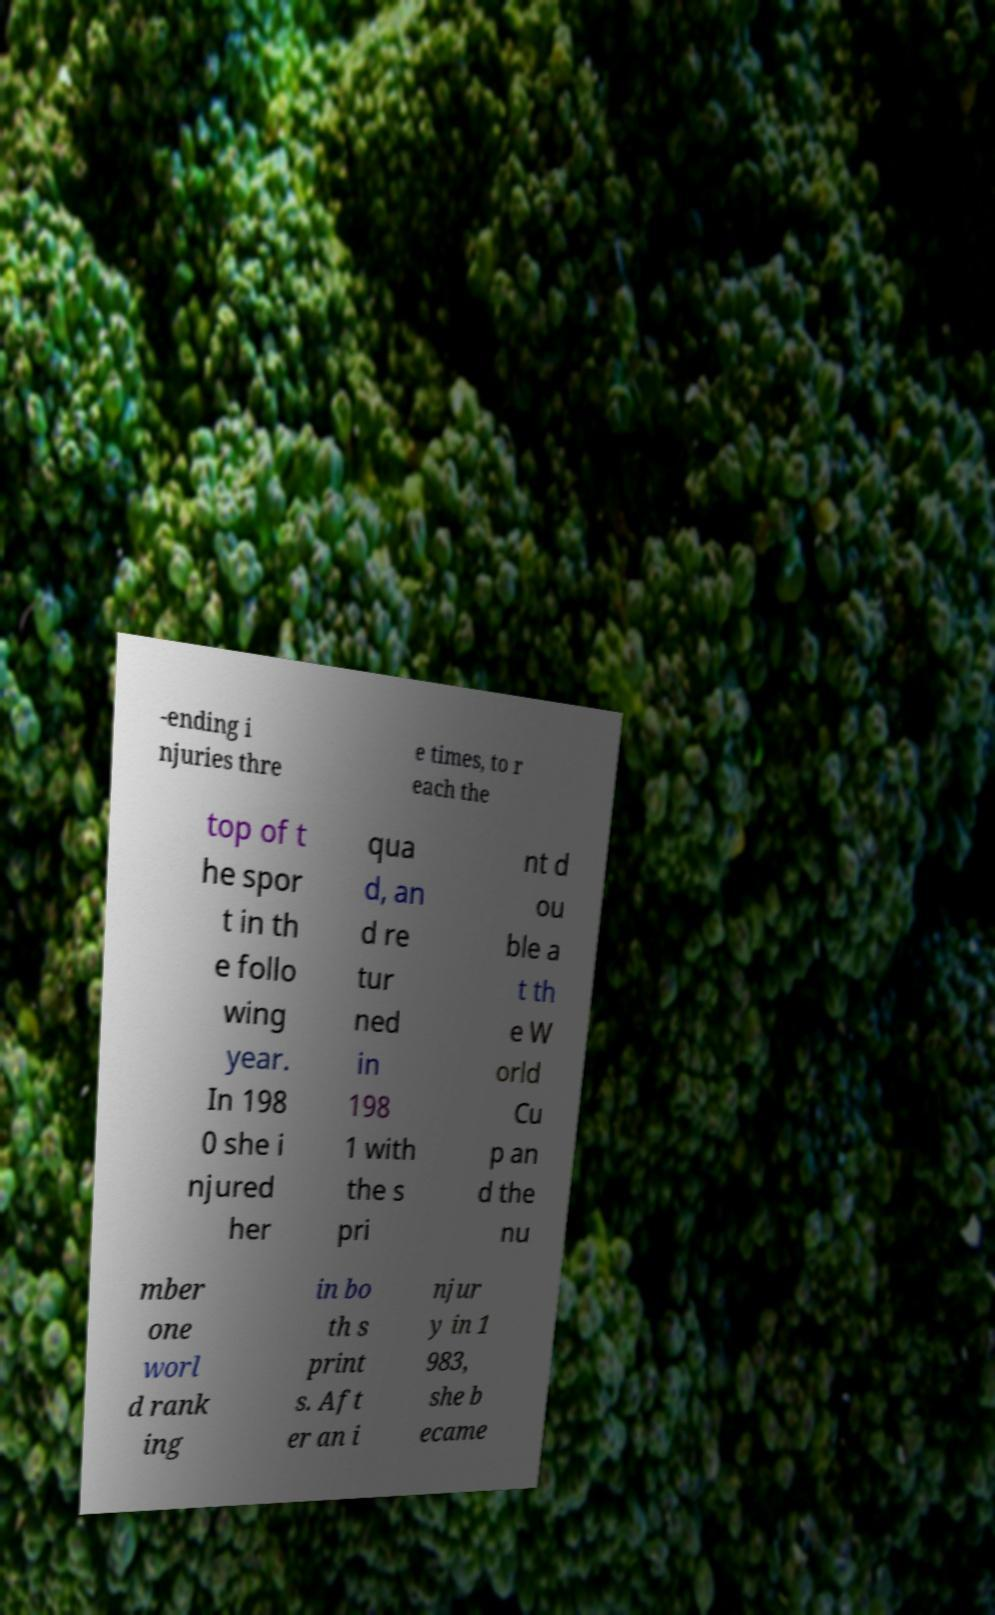For documentation purposes, I need the text within this image transcribed. Could you provide that? -ending i njuries thre e times, to r each the top of t he spor t in th e follo wing year. In 198 0 she i njured her qua d, an d re tur ned in 198 1 with the s pri nt d ou ble a t th e W orld Cu p an d the nu mber one worl d rank ing in bo th s print s. Aft er an i njur y in 1 983, she b ecame 